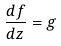<formula> <loc_0><loc_0><loc_500><loc_500>\frac { d f } { d z } = g</formula> 